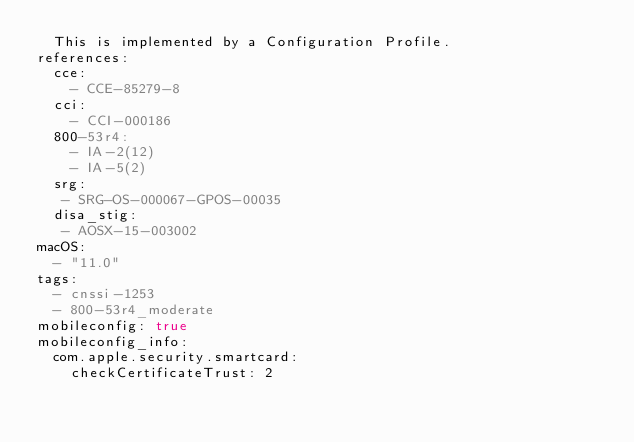<code> <loc_0><loc_0><loc_500><loc_500><_YAML_>  This is implemented by a Configuration Profile.
references:
  cce:
    - CCE-85279-8
  cci: 
    - CCI-000186
  800-53r4: 
    - IA-2(12)
    - IA-5(2)
  srg: 
   - SRG-OS-000067-GPOS-00035
  disa_stig: 
   - AOSX-15-003002
macOS:
  - "11.0"
tags:
  - cnssi-1253
  - 800-53r4_moderate
mobileconfig: true
mobileconfig_info:
  com.apple.security.smartcard:
    checkCertificateTrust: 2
</code> 